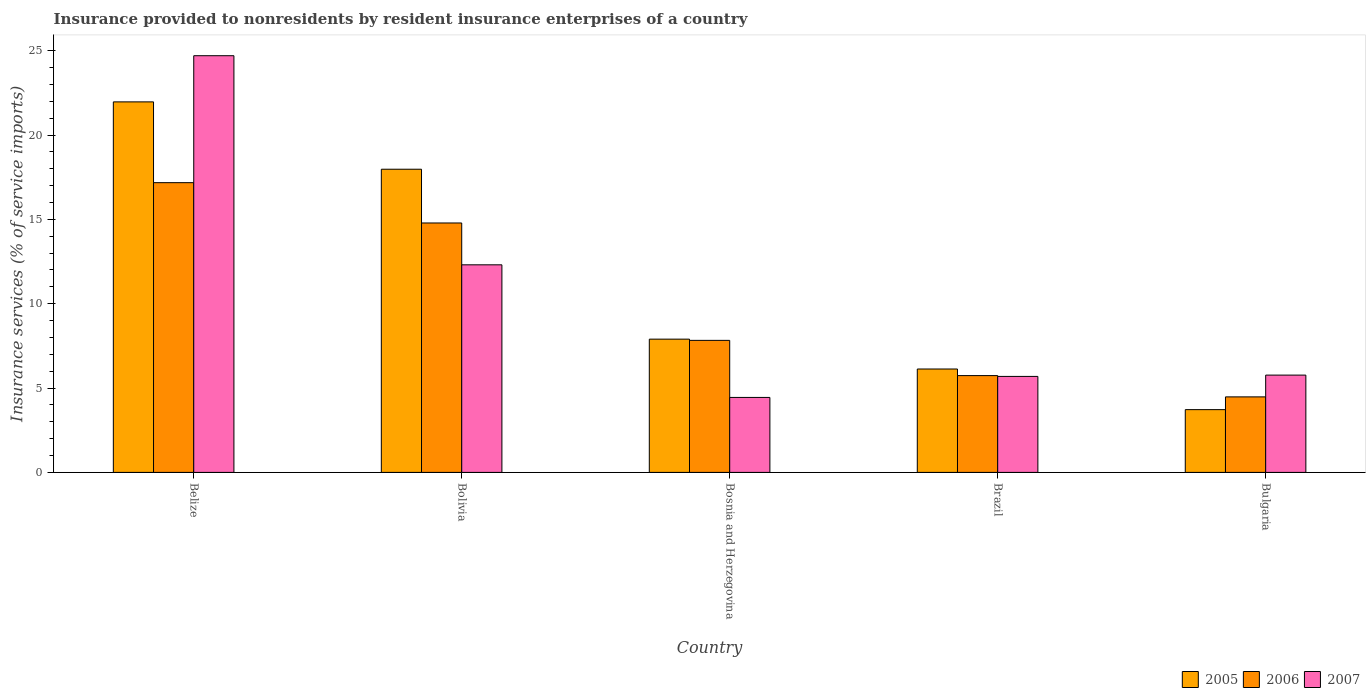How many different coloured bars are there?
Provide a succinct answer. 3. Are the number of bars on each tick of the X-axis equal?
Ensure brevity in your answer.  Yes. How many bars are there on the 3rd tick from the left?
Your response must be concise. 3. How many bars are there on the 3rd tick from the right?
Provide a short and direct response. 3. What is the label of the 4th group of bars from the left?
Your answer should be very brief. Brazil. What is the insurance provided to nonresidents in 2007 in Bosnia and Herzegovina?
Offer a very short reply. 4.44. Across all countries, what is the maximum insurance provided to nonresidents in 2007?
Offer a very short reply. 24.7. Across all countries, what is the minimum insurance provided to nonresidents in 2007?
Your answer should be compact. 4.44. In which country was the insurance provided to nonresidents in 2005 maximum?
Offer a terse response. Belize. In which country was the insurance provided to nonresidents in 2006 minimum?
Offer a very short reply. Bulgaria. What is the total insurance provided to nonresidents in 2006 in the graph?
Offer a terse response. 50. What is the difference between the insurance provided to nonresidents in 2006 in Bolivia and that in Bosnia and Herzegovina?
Your response must be concise. 6.96. What is the difference between the insurance provided to nonresidents in 2007 in Bosnia and Herzegovina and the insurance provided to nonresidents in 2005 in Brazil?
Your answer should be very brief. -1.69. What is the average insurance provided to nonresidents in 2007 per country?
Your answer should be very brief. 10.58. What is the difference between the insurance provided to nonresidents of/in 2006 and insurance provided to nonresidents of/in 2007 in Brazil?
Make the answer very short. 0.05. What is the ratio of the insurance provided to nonresidents in 2006 in Bolivia to that in Bulgaria?
Ensure brevity in your answer.  3.3. What is the difference between the highest and the second highest insurance provided to nonresidents in 2007?
Your response must be concise. 12.4. What is the difference between the highest and the lowest insurance provided to nonresidents in 2007?
Ensure brevity in your answer.  20.26. Is the sum of the insurance provided to nonresidents in 2007 in Brazil and Bulgaria greater than the maximum insurance provided to nonresidents in 2006 across all countries?
Offer a very short reply. No. What does the 1st bar from the right in Bosnia and Herzegovina represents?
Provide a short and direct response. 2007. Is it the case that in every country, the sum of the insurance provided to nonresidents in 2007 and insurance provided to nonresidents in 2006 is greater than the insurance provided to nonresidents in 2005?
Provide a succinct answer. Yes. How many bars are there?
Your answer should be compact. 15. How many countries are there in the graph?
Give a very brief answer. 5. Does the graph contain any zero values?
Offer a terse response. No. Where does the legend appear in the graph?
Your answer should be compact. Bottom right. How are the legend labels stacked?
Your answer should be very brief. Horizontal. What is the title of the graph?
Give a very brief answer. Insurance provided to nonresidents by resident insurance enterprises of a country. What is the label or title of the X-axis?
Your answer should be very brief. Country. What is the label or title of the Y-axis?
Give a very brief answer. Insurance services (% of service imports). What is the Insurance services (% of service imports) of 2005 in Belize?
Ensure brevity in your answer.  21.96. What is the Insurance services (% of service imports) of 2006 in Belize?
Your answer should be very brief. 17.18. What is the Insurance services (% of service imports) of 2007 in Belize?
Ensure brevity in your answer.  24.7. What is the Insurance services (% of service imports) of 2005 in Bolivia?
Provide a succinct answer. 17.97. What is the Insurance services (% of service imports) in 2006 in Bolivia?
Give a very brief answer. 14.79. What is the Insurance services (% of service imports) in 2007 in Bolivia?
Offer a terse response. 12.31. What is the Insurance services (% of service imports) in 2005 in Bosnia and Herzegovina?
Your answer should be very brief. 7.9. What is the Insurance services (% of service imports) of 2006 in Bosnia and Herzegovina?
Your answer should be compact. 7.83. What is the Insurance services (% of service imports) of 2007 in Bosnia and Herzegovina?
Provide a short and direct response. 4.44. What is the Insurance services (% of service imports) of 2005 in Brazil?
Offer a very short reply. 6.13. What is the Insurance services (% of service imports) in 2006 in Brazil?
Ensure brevity in your answer.  5.74. What is the Insurance services (% of service imports) in 2007 in Brazil?
Your response must be concise. 5.69. What is the Insurance services (% of service imports) of 2005 in Bulgaria?
Your answer should be compact. 3.72. What is the Insurance services (% of service imports) in 2006 in Bulgaria?
Your answer should be compact. 4.48. What is the Insurance services (% of service imports) of 2007 in Bulgaria?
Provide a short and direct response. 5.77. Across all countries, what is the maximum Insurance services (% of service imports) of 2005?
Keep it short and to the point. 21.96. Across all countries, what is the maximum Insurance services (% of service imports) of 2006?
Your answer should be very brief. 17.18. Across all countries, what is the maximum Insurance services (% of service imports) of 2007?
Offer a very short reply. 24.7. Across all countries, what is the minimum Insurance services (% of service imports) of 2005?
Offer a terse response. 3.72. Across all countries, what is the minimum Insurance services (% of service imports) of 2006?
Your response must be concise. 4.48. Across all countries, what is the minimum Insurance services (% of service imports) of 2007?
Offer a very short reply. 4.44. What is the total Insurance services (% of service imports) in 2005 in the graph?
Your response must be concise. 57.69. What is the total Insurance services (% of service imports) of 2006 in the graph?
Your response must be concise. 50. What is the total Insurance services (% of service imports) in 2007 in the graph?
Provide a succinct answer. 52.91. What is the difference between the Insurance services (% of service imports) in 2005 in Belize and that in Bolivia?
Give a very brief answer. 3.99. What is the difference between the Insurance services (% of service imports) in 2006 in Belize and that in Bolivia?
Offer a very short reply. 2.39. What is the difference between the Insurance services (% of service imports) in 2007 in Belize and that in Bolivia?
Your answer should be very brief. 12.4. What is the difference between the Insurance services (% of service imports) of 2005 in Belize and that in Bosnia and Herzegovina?
Provide a succinct answer. 14.07. What is the difference between the Insurance services (% of service imports) of 2006 in Belize and that in Bosnia and Herzegovina?
Your answer should be compact. 9.35. What is the difference between the Insurance services (% of service imports) in 2007 in Belize and that in Bosnia and Herzegovina?
Your answer should be very brief. 20.26. What is the difference between the Insurance services (% of service imports) of 2005 in Belize and that in Brazil?
Provide a succinct answer. 15.84. What is the difference between the Insurance services (% of service imports) of 2006 in Belize and that in Brazil?
Your answer should be compact. 11.44. What is the difference between the Insurance services (% of service imports) of 2007 in Belize and that in Brazil?
Offer a terse response. 19.01. What is the difference between the Insurance services (% of service imports) in 2005 in Belize and that in Bulgaria?
Your answer should be compact. 18.24. What is the difference between the Insurance services (% of service imports) of 2006 in Belize and that in Bulgaria?
Give a very brief answer. 12.7. What is the difference between the Insurance services (% of service imports) in 2007 in Belize and that in Bulgaria?
Give a very brief answer. 18.93. What is the difference between the Insurance services (% of service imports) in 2005 in Bolivia and that in Bosnia and Herzegovina?
Your answer should be compact. 10.07. What is the difference between the Insurance services (% of service imports) of 2006 in Bolivia and that in Bosnia and Herzegovina?
Offer a terse response. 6.96. What is the difference between the Insurance services (% of service imports) in 2007 in Bolivia and that in Bosnia and Herzegovina?
Your answer should be very brief. 7.86. What is the difference between the Insurance services (% of service imports) of 2005 in Bolivia and that in Brazil?
Your answer should be compact. 11.84. What is the difference between the Insurance services (% of service imports) of 2006 in Bolivia and that in Brazil?
Offer a terse response. 9.05. What is the difference between the Insurance services (% of service imports) of 2007 in Bolivia and that in Brazil?
Keep it short and to the point. 6.62. What is the difference between the Insurance services (% of service imports) in 2005 in Bolivia and that in Bulgaria?
Provide a succinct answer. 14.25. What is the difference between the Insurance services (% of service imports) in 2006 in Bolivia and that in Bulgaria?
Offer a very short reply. 10.31. What is the difference between the Insurance services (% of service imports) in 2007 in Bolivia and that in Bulgaria?
Offer a terse response. 6.54. What is the difference between the Insurance services (% of service imports) in 2005 in Bosnia and Herzegovina and that in Brazil?
Your response must be concise. 1.77. What is the difference between the Insurance services (% of service imports) in 2006 in Bosnia and Herzegovina and that in Brazil?
Your answer should be very brief. 2.09. What is the difference between the Insurance services (% of service imports) of 2007 in Bosnia and Herzegovina and that in Brazil?
Your answer should be compact. -1.25. What is the difference between the Insurance services (% of service imports) in 2005 in Bosnia and Herzegovina and that in Bulgaria?
Give a very brief answer. 4.18. What is the difference between the Insurance services (% of service imports) in 2006 in Bosnia and Herzegovina and that in Bulgaria?
Give a very brief answer. 3.35. What is the difference between the Insurance services (% of service imports) in 2007 in Bosnia and Herzegovina and that in Bulgaria?
Provide a short and direct response. -1.32. What is the difference between the Insurance services (% of service imports) of 2005 in Brazil and that in Bulgaria?
Ensure brevity in your answer.  2.41. What is the difference between the Insurance services (% of service imports) of 2006 in Brazil and that in Bulgaria?
Offer a very short reply. 1.26. What is the difference between the Insurance services (% of service imports) in 2007 in Brazil and that in Bulgaria?
Give a very brief answer. -0.08. What is the difference between the Insurance services (% of service imports) in 2005 in Belize and the Insurance services (% of service imports) in 2006 in Bolivia?
Keep it short and to the point. 7.18. What is the difference between the Insurance services (% of service imports) in 2005 in Belize and the Insurance services (% of service imports) in 2007 in Bolivia?
Your answer should be compact. 9.66. What is the difference between the Insurance services (% of service imports) in 2006 in Belize and the Insurance services (% of service imports) in 2007 in Bolivia?
Give a very brief answer. 4.87. What is the difference between the Insurance services (% of service imports) of 2005 in Belize and the Insurance services (% of service imports) of 2006 in Bosnia and Herzegovina?
Your response must be concise. 14.14. What is the difference between the Insurance services (% of service imports) in 2005 in Belize and the Insurance services (% of service imports) in 2007 in Bosnia and Herzegovina?
Give a very brief answer. 17.52. What is the difference between the Insurance services (% of service imports) of 2006 in Belize and the Insurance services (% of service imports) of 2007 in Bosnia and Herzegovina?
Ensure brevity in your answer.  12.73. What is the difference between the Insurance services (% of service imports) in 2005 in Belize and the Insurance services (% of service imports) in 2006 in Brazil?
Provide a short and direct response. 16.23. What is the difference between the Insurance services (% of service imports) of 2005 in Belize and the Insurance services (% of service imports) of 2007 in Brazil?
Offer a terse response. 16.27. What is the difference between the Insurance services (% of service imports) in 2006 in Belize and the Insurance services (% of service imports) in 2007 in Brazil?
Make the answer very short. 11.49. What is the difference between the Insurance services (% of service imports) of 2005 in Belize and the Insurance services (% of service imports) of 2006 in Bulgaria?
Your answer should be very brief. 17.49. What is the difference between the Insurance services (% of service imports) of 2005 in Belize and the Insurance services (% of service imports) of 2007 in Bulgaria?
Offer a very short reply. 16.2. What is the difference between the Insurance services (% of service imports) in 2006 in Belize and the Insurance services (% of service imports) in 2007 in Bulgaria?
Your response must be concise. 11.41. What is the difference between the Insurance services (% of service imports) in 2005 in Bolivia and the Insurance services (% of service imports) in 2006 in Bosnia and Herzegovina?
Provide a short and direct response. 10.15. What is the difference between the Insurance services (% of service imports) in 2005 in Bolivia and the Insurance services (% of service imports) in 2007 in Bosnia and Herzegovina?
Ensure brevity in your answer.  13.53. What is the difference between the Insurance services (% of service imports) of 2006 in Bolivia and the Insurance services (% of service imports) of 2007 in Bosnia and Herzegovina?
Provide a short and direct response. 10.34. What is the difference between the Insurance services (% of service imports) of 2005 in Bolivia and the Insurance services (% of service imports) of 2006 in Brazil?
Give a very brief answer. 12.23. What is the difference between the Insurance services (% of service imports) in 2005 in Bolivia and the Insurance services (% of service imports) in 2007 in Brazil?
Provide a succinct answer. 12.28. What is the difference between the Insurance services (% of service imports) of 2006 in Bolivia and the Insurance services (% of service imports) of 2007 in Brazil?
Your answer should be compact. 9.1. What is the difference between the Insurance services (% of service imports) in 2005 in Bolivia and the Insurance services (% of service imports) in 2006 in Bulgaria?
Ensure brevity in your answer.  13.5. What is the difference between the Insurance services (% of service imports) of 2005 in Bolivia and the Insurance services (% of service imports) of 2007 in Bulgaria?
Provide a succinct answer. 12.2. What is the difference between the Insurance services (% of service imports) of 2006 in Bolivia and the Insurance services (% of service imports) of 2007 in Bulgaria?
Provide a short and direct response. 9.02. What is the difference between the Insurance services (% of service imports) of 2005 in Bosnia and Herzegovina and the Insurance services (% of service imports) of 2006 in Brazil?
Keep it short and to the point. 2.16. What is the difference between the Insurance services (% of service imports) in 2005 in Bosnia and Herzegovina and the Insurance services (% of service imports) in 2007 in Brazil?
Your answer should be very brief. 2.21. What is the difference between the Insurance services (% of service imports) in 2006 in Bosnia and Herzegovina and the Insurance services (% of service imports) in 2007 in Brazil?
Your answer should be very brief. 2.14. What is the difference between the Insurance services (% of service imports) of 2005 in Bosnia and Herzegovina and the Insurance services (% of service imports) of 2006 in Bulgaria?
Give a very brief answer. 3.42. What is the difference between the Insurance services (% of service imports) in 2005 in Bosnia and Herzegovina and the Insurance services (% of service imports) in 2007 in Bulgaria?
Keep it short and to the point. 2.13. What is the difference between the Insurance services (% of service imports) in 2006 in Bosnia and Herzegovina and the Insurance services (% of service imports) in 2007 in Bulgaria?
Your response must be concise. 2.06. What is the difference between the Insurance services (% of service imports) of 2005 in Brazil and the Insurance services (% of service imports) of 2006 in Bulgaria?
Offer a terse response. 1.65. What is the difference between the Insurance services (% of service imports) in 2005 in Brazil and the Insurance services (% of service imports) in 2007 in Bulgaria?
Give a very brief answer. 0.36. What is the difference between the Insurance services (% of service imports) of 2006 in Brazil and the Insurance services (% of service imports) of 2007 in Bulgaria?
Give a very brief answer. -0.03. What is the average Insurance services (% of service imports) in 2005 per country?
Provide a short and direct response. 11.54. What is the average Insurance services (% of service imports) in 2006 per country?
Your response must be concise. 10. What is the average Insurance services (% of service imports) in 2007 per country?
Give a very brief answer. 10.58. What is the difference between the Insurance services (% of service imports) of 2005 and Insurance services (% of service imports) of 2006 in Belize?
Give a very brief answer. 4.79. What is the difference between the Insurance services (% of service imports) of 2005 and Insurance services (% of service imports) of 2007 in Belize?
Your answer should be very brief. -2.74. What is the difference between the Insurance services (% of service imports) of 2006 and Insurance services (% of service imports) of 2007 in Belize?
Your answer should be very brief. -7.53. What is the difference between the Insurance services (% of service imports) of 2005 and Insurance services (% of service imports) of 2006 in Bolivia?
Provide a succinct answer. 3.19. What is the difference between the Insurance services (% of service imports) of 2005 and Insurance services (% of service imports) of 2007 in Bolivia?
Your answer should be very brief. 5.67. What is the difference between the Insurance services (% of service imports) of 2006 and Insurance services (% of service imports) of 2007 in Bolivia?
Provide a succinct answer. 2.48. What is the difference between the Insurance services (% of service imports) of 2005 and Insurance services (% of service imports) of 2006 in Bosnia and Herzegovina?
Provide a short and direct response. 0.07. What is the difference between the Insurance services (% of service imports) of 2005 and Insurance services (% of service imports) of 2007 in Bosnia and Herzegovina?
Your answer should be very brief. 3.46. What is the difference between the Insurance services (% of service imports) in 2006 and Insurance services (% of service imports) in 2007 in Bosnia and Herzegovina?
Your answer should be very brief. 3.38. What is the difference between the Insurance services (% of service imports) in 2005 and Insurance services (% of service imports) in 2006 in Brazil?
Keep it short and to the point. 0.39. What is the difference between the Insurance services (% of service imports) of 2005 and Insurance services (% of service imports) of 2007 in Brazil?
Keep it short and to the point. 0.44. What is the difference between the Insurance services (% of service imports) of 2006 and Insurance services (% of service imports) of 2007 in Brazil?
Give a very brief answer. 0.05. What is the difference between the Insurance services (% of service imports) of 2005 and Insurance services (% of service imports) of 2006 in Bulgaria?
Your answer should be compact. -0.76. What is the difference between the Insurance services (% of service imports) in 2005 and Insurance services (% of service imports) in 2007 in Bulgaria?
Your response must be concise. -2.05. What is the difference between the Insurance services (% of service imports) in 2006 and Insurance services (% of service imports) in 2007 in Bulgaria?
Make the answer very short. -1.29. What is the ratio of the Insurance services (% of service imports) of 2005 in Belize to that in Bolivia?
Keep it short and to the point. 1.22. What is the ratio of the Insurance services (% of service imports) of 2006 in Belize to that in Bolivia?
Offer a terse response. 1.16. What is the ratio of the Insurance services (% of service imports) in 2007 in Belize to that in Bolivia?
Give a very brief answer. 2.01. What is the ratio of the Insurance services (% of service imports) of 2005 in Belize to that in Bosnia and Herzegovina?
Provide a short and direct response. 2.78. What is the ratio of the Insurance services (% of service imports) of 2006 in Belize to that in Bosnia and Herzegovina?
Your response must be concise. 2.19. What is the ratio of the Insurance services (% of service imports) in 2007 in Belize to that in Bosnia and Herzegovina?
Keep it short and to the point. 5.56. What is the ratio of the Insurance services (% of service imports) of 2005 in Belize to that in Brazil?
Your response must be concise. 3.58. What is the ratio of the Insurance services (% of service imports) of 2006 in Belize to that in Brazil?
Provide a short and direct response. 2.99. What is the ratio of the Insurance services (% of service imports) in 2007 in Belize to that in Brazil?
Your response must be concise. 4.34. What is the ratio of the Insurance services (% of service imports) in 2005 in Belize to that in Bulgaria?
Provide a short and direct response. 5.9. What is the ratio of the Insurance services (% of service imports) in 2006 in Belize to that in Bulgaria?
Provide a short and direct response. 3.84. What is the ratio of the Insurance services (% of service imports) in 2007 in Belize to that in Bulgaria?
Ensure brevity in your answer.  4.28. What is the ratio of the Insurance services (% of service imports) in 2005 in Bolivia to that in Bosnia and Herzegovina?
Your answer should be very brief. 2.28. What is the ratio of the Insurance services (% of service imports) in 2006 in Bolivia to that in Bosnia and Herzegovina?
Make the answer very short. 1.89. What is the ratio of the Insurance services (% of service imports) in 2007 in Bolivia to that in Bosnia and Herzegovina?
Give a very brief answer. 2.77. What is the ratio of the Insurance services (% of service imports) in 2005 in Bolivia to that in Brazil?
Offer a terse response. 2.93. What is the ratio of the Insurance services (% of service imports) of 2006 in Bolivia to that in Brazil?
Your answer should be compact. 2.58. What is the ratio of the Insurance services (% of service imports) in 2007 in Bolivia to that in Brazil?
Your answer should be very brief. 2.16. What is the ratio of the Insurance services (% of service imports) of 2005 in Bolivia to that in Bulgaria?
Offer a very short reply. 4.83. What is the ratio of the Insurance services (% of service imports) in 2006 in Bolivia to that in Bulgaria?
Your answer should be very brief. 3.3. What is the ratio of the Insurance services (% of service imports) in 2007 in Bolivia to that in Bulgaria?
Offer a very short reply. 2.13. What is the ratio of the Insurance services (% of service imports) in 2005 in Bosnia and Herzegovina to that in Brazil?
Your answer should be very brief. 1.29. What is the ratio of the Insurance services (% of service imports) of 2006 in Bosnia and Herzegovina to that in Brazil?
Provide a short and direct response. 1.36. What is the ratio of the Insurance services (% of service imports) in 2007 in Bosnia and Herzegovina to that in Brazil?
Offer a terse response. 0.78. What is the ratio of the Insurance services (% of service imports) in 2005 in Bosnia and Herzegovina to that in Bulgaria?
Your answer should be compact. 2.12. What is the ratio of the Insurance services (% of service imports) in 2006 in Bosnia and Herzegovina to that in Bulgaria?
Provide a short and direct response. 1.75. What is the ratio of the Insurance services (% of service imports) of 2007 in Bosnia and Herzegovina to that in Bulgaria?
Your answer should be compact. 0.77. What is the ratio of the Insurance services (% of service imports) of 2005 in Brazil to that in Bulgaria?
Give a very brief answer. 1.65. What is the ratio of the Insurance services (% of service imports) in 2006 in Brazil to that in Bulgaria?
Your answer should be very brief. 1.28. What is the ratio of the Insurance services (% of service imports) of 2007 in Brazil to that in Bulgaria?
Make the answer very short. 0.99. What is the difference between the highest and the second highest Insurance services (% of service imports) in 2005?
Keep it short and to the point. 3.99. What is the difference between the highest and the second highest Insurance services (% of service imports) in 2006?
Provide a short and direct response. 2.39. What is the difference between the highest and the second highest Insurance services (% of service imports) in 2007?
Offer a terse response. 12.4. What is the difference between the highest and the lowest Insurance services (% of service imports) in 2005?
Ensure brevity in your answer.  18.24. What is the difference between the highest and the lowest Insurance services (% of service imports) in 2006?
Keep it short and to the point. 12.7. What is the difference between the highest and the lowest Insurance services (% of service imports) of 2007?
Offer a very short reply. 20.26. 